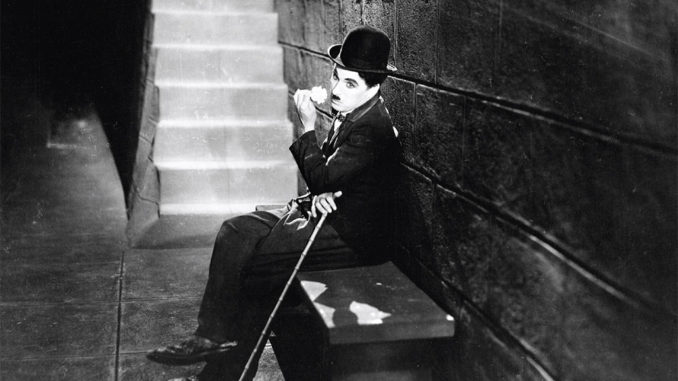What emotions do you think Chaplin's character might be feeling in this moment? Charlie Chaplin's character, the Tramp, appears to be enveloped in a moment of deep contemplation. His thoughtful gaze and relaxed posture suggest a combination of nostalgia and quiet resilience. Perhaps he is reflecting on past adventures and the challenges he's faced, or maybe he's simply soaking in a rare moment of peace. The Tramp's expression hints at a bittersweet mix of melancholy and hope, emotions that resonate with audiences and add to the timeless appeal of his character. 